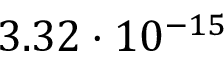<formula> <loc_0><loc_0><loc_500><loc_500>3 . 3 2 \cdot 1 0 ^ { - 1 5 }</formula> 